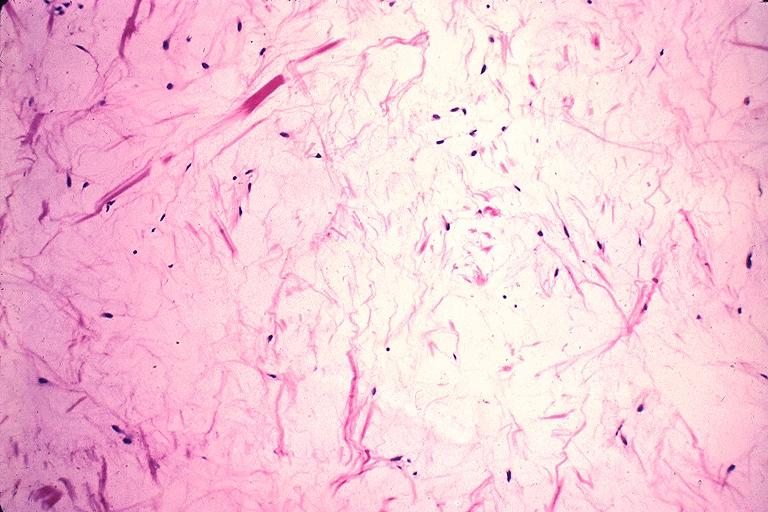s beckwith-wiedemann syndrome present?
Answer the question using a single word or phrase. No 